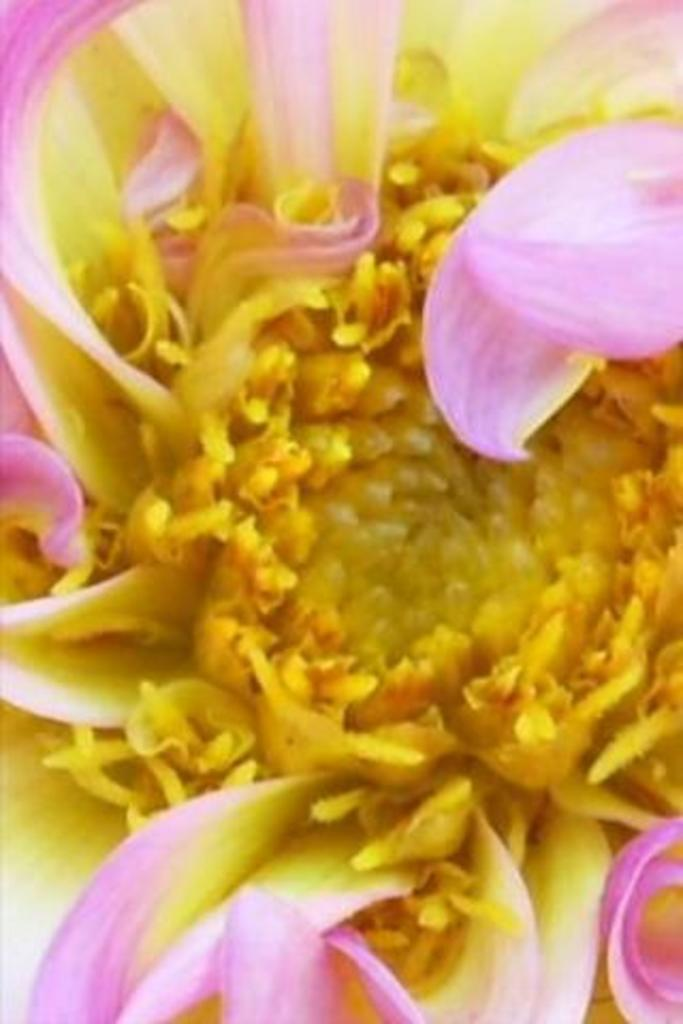What is the main subject of the image? There is a flower in the image. What color is the flower? The flower is pink in color. Can you describe any specific features of the flower? Pollen grains are visible in the middle of the flower. How does the flower contribute to the wealth of the person in the image? There is no person present in the image, and the flower's wealth contribution cannot be determined. 